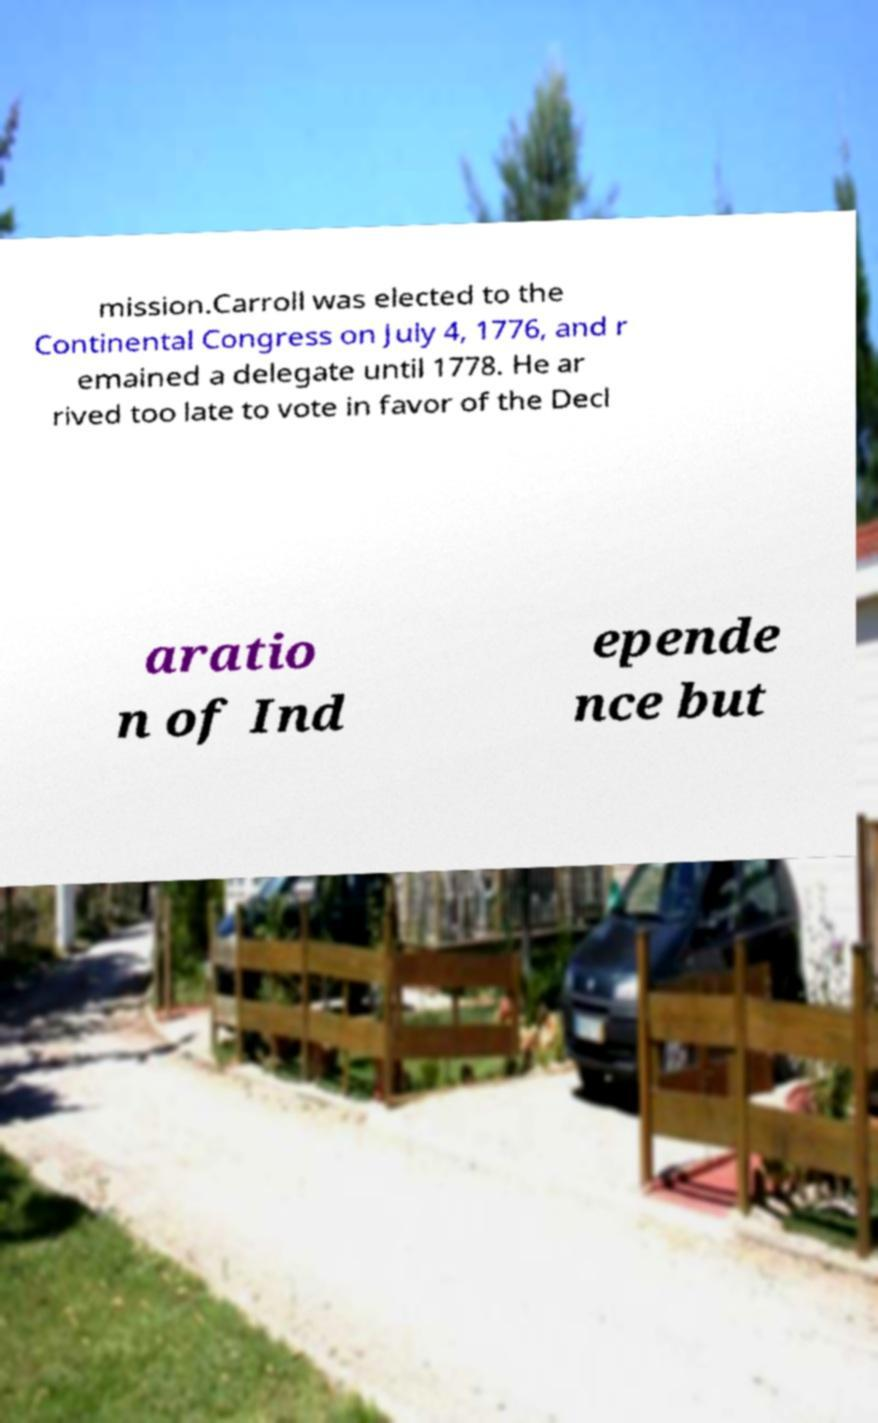What messages or text are displayed in this image? I need them in a readable, typed format. mission.Carroll was elected to the Continental Congress on July 4, 1776, and r emained a delegate until 1778. He ar rived too late to vote in favor of the Decl aratio n of Ind epende nce but 